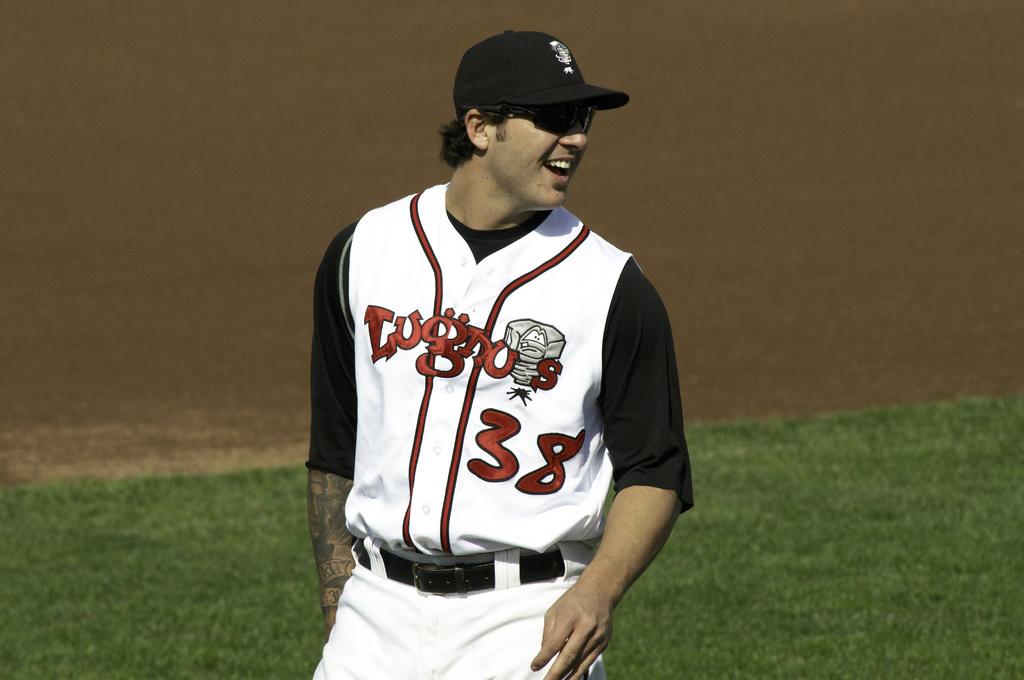What is the number of that sports player?
Keep it short and to the point. 38. What is the team name?
Offer a very short reply. Lugnuts. 